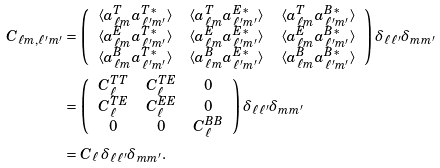Convert formula to latex. <formula><loc_0><loc_0><loc_500><loc_500>C _ { \ell m , \ell ^ { \prime } m ^ { \prime } } & = \left ( \begin{array} { c c c } \left < a _ { \ell m } ^ { T } a _ { \ell ^ { \prime } m ^ { \prime } } ^ { T * } \right > & \left < a _ { \ell m } ^ { T } a _ { \ell ^ { \prime } m ^ { \prime } } ^ { E * } \right > & \left < a _ { \ell m } ^ { T } a _ { \ell ^ { \prime } m ^ { \prime } } ^ { B * } \right > \\ \left < a _ { \ell m } ^ { E } a _ { \ell ^ { \prime } m ^ { \prime } } ^ { T * } \right > & \left < a _ { \ell m } ^ { E } a _ { \ell ^ { \prime } m ^ { \prime } } ^ { E * } \right > & \left < a _ { \ell m } ^ { E } a _ { \ell ^ { \prime } m ^ { \prime } } ^ { B * } \right > \\ \left < a _ { \ell m } ^ { B } a _ { \ell ^ { \prime } m ^ { \prime } } ^ { T * } \right > & \left < a _ { \ell m } ^ { B } a _ { \ell ^ { \prime } m ^ { \prime } } ^ { E * } \right > & \left < a _ { \ell m } ^ { B } a _ { \ell ^ { \prime } m ^ { \prime } } ^ { B * } \right > \end{array} \right ) \delta _ { \ell \ell ^ { \prime } } \delta _ { m m ^ { \prime } } \\ & = \left ( \begin{array} { c c c } C _ { \ell } ^ { T T } & C _ { \ell } ^ { T E } & 0 \\ C _ { \ell } ^ { T E } & C _ { \ell } ^ { E E } & 0 \\ 0 & 0 & C _ { \ell } ^ { B B } \end{array} \right ) \delta _ { \ell \ell ^ { \prime } } \delta _ { m m ^ { \prime } } \\ & = C _ { \ell } \, \delta _ { \ell \ell ^ { \prime } } \delta _ { m m ^ { \prime } } .</formula> 